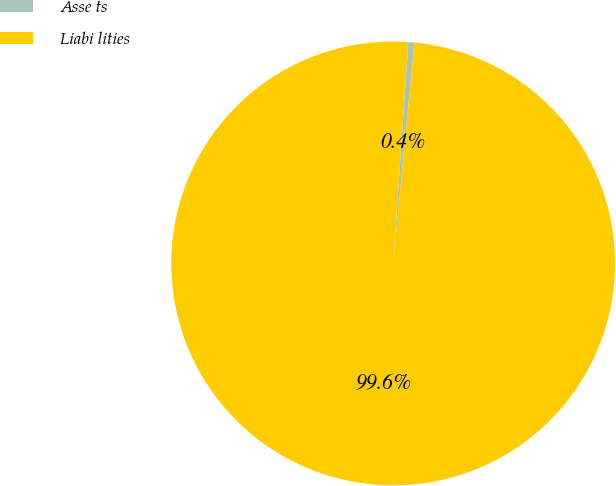Convert chart to OTSL. <chart><loc_0><loc_0><loc_500><loc_500><pie_chart><fcel>Asse ts<fcel>Liabi lities<nl><fcel>0.44%<fcel>99.56%<nl></chart> 